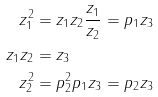Convert formula to latex. <formula><loc_0><loc_0><loc_500><loc_500>z _ { 1 } ^ { 2 } & = z _ { 1 } z _ { 2 } \frac { z _ { 1 } } { z _ { 2 } } = p _ { 1 } z _ { 3 } \\ z _ { 1 } z _ { 2 } & = z _ { 3 } \\ z _ { 2 } ^ { 2 } & = p _ { 2 } ^ { 2 } p _ { 1 } z _ { 3 } = p _ { 2 } z _ { 3 }</formula> 